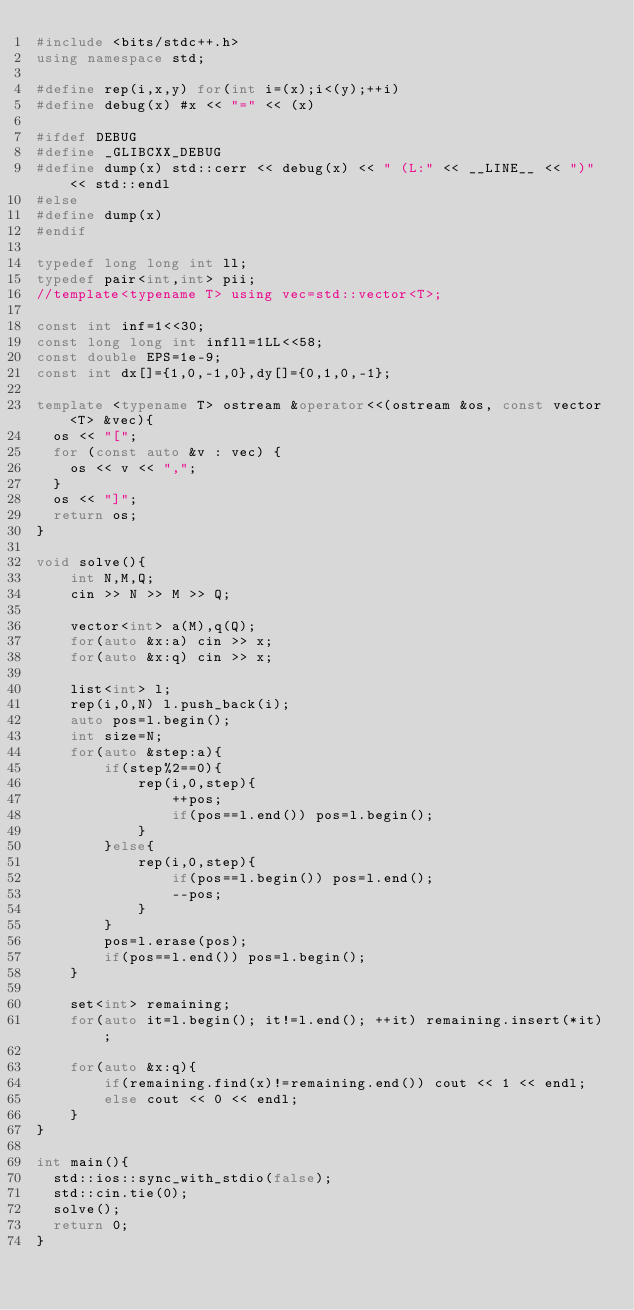Convert code to text. <code><loc_0><loc_0><loc_500><loc_500><_C++_>#include <bits/stdc++.h>
using namespace std;

#define rep(i,x,y) for(int i=(x);i<(y);++i)
#define debug(x) #x << "=" << (x)
 
#ifdef DEBUG
#define _GLIBCXX_DEBUG
#define dump(x) std::cerr << debug(x) << " (L:" << __LINE__ << ")" << std::endl
#else
#define dump(x)
#endif

typedef long long int ll;
typedef pair<int,int> pii;
//template<typename T> using vec=std::vector<T>;

const int inf=1<<30;
const long long int infll=1LL<<58;
const double EPS=1e-9;
const int dx[]={1,0,-1,0},dy[]={0,1,0,-1};

template <typename T> ostream &operator<<(ostream &os, const vector<T> &vec){
	os << "[";
	for (const auto &v : vec) {
		os << v << ",";
	}
	os << "]";
	return os;
}

void solve(){
    int N,M,Q;
    cin >> N >> M >> Q;
    
    vector<int> a(M),q(Q);
    for(auto &x:a) cin >> x;
    for(auto &x:q) cin >> x;
    
    list<int> l;
    rep(i,0,N) l.push_back(i);
    auto pos=l.begin();
    int size=N;
    for(auto &step:a){
        if(step%2==0){
            rep(i,0,step){
                ++pos;
                if(pos==l.end()) pos=l.begin();
            }
        }else{
            rep(i,0,step){
                if(pos==l.begin()) pos=l.end();
                --pos;
            }
        }
        pos=l.erase(pos);
        if(pos==l.end()) pos=l.begin();
    }
    
    set<int> remaining;
    for(auto it=l.begin(); it!=l.end(); ++it) remaining.insert(*it);
    
    for(auto &x:q){
        if(remaining.find(x)!=remaining.end()) cout << 1 << endl;
        else cout << 0 << endl;
    }
}

int main(){
	std::ios::sync_with_stdio(false);
	std::cin.tie(0);
	solve();
	return 0;
}</code> 